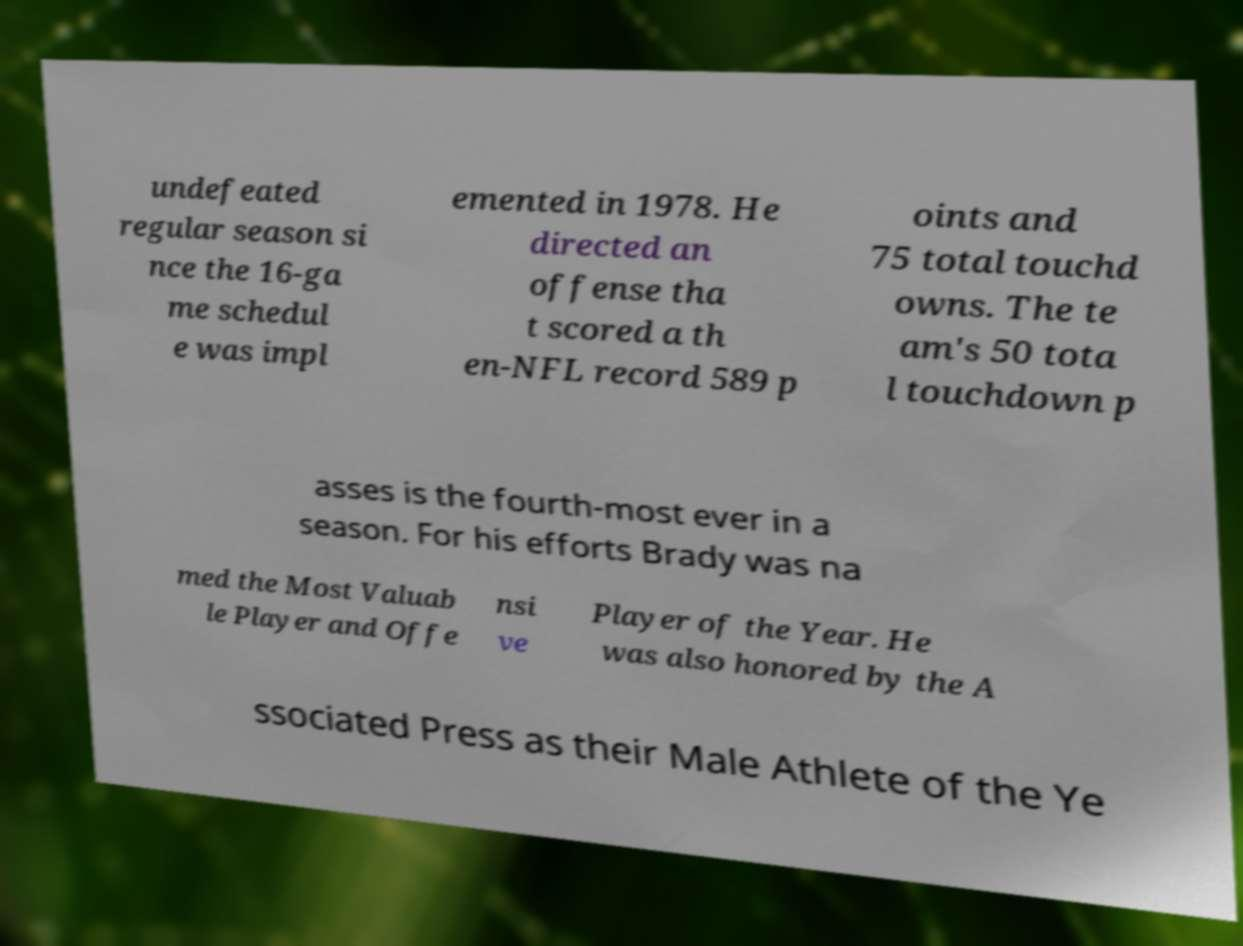Can you accurately transcribe the text from the provided image for me? undefeated regular season si nce the 16-ga me schedul e was impl emented in 1978. He directed an offense tha t scored a th en-NFL record 589 p oints and 75 total touchd owns. The te am's 50 tota l touchdown p asses is the fourth-most ever in a season. For his efforts Brady was na med the Most Valuab le Player and Offe nsi ve Player of the Year. He was also honored by the A ssociated Press as their Male Athlete of the Ye 